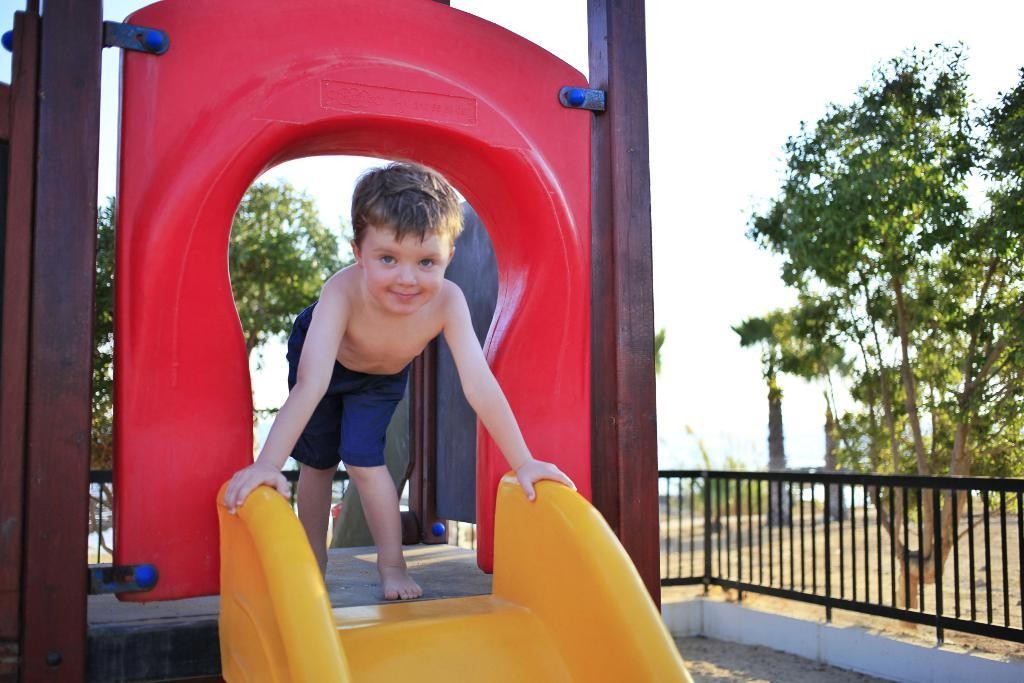What is the main subject of the image? There is a park's ride in the image. Who is on the park's ride? A boy is on the park's ride. What is the boy wearing? The boy is wearing shorts. What can be seen in the background of the image? There is railing and multiple trees visible in the background of the image. How many giants can be seen in the image? There are no giants present in the image. What type of headwear is the boy wearing in the image? The boy is not wearing any headwear in the image. 